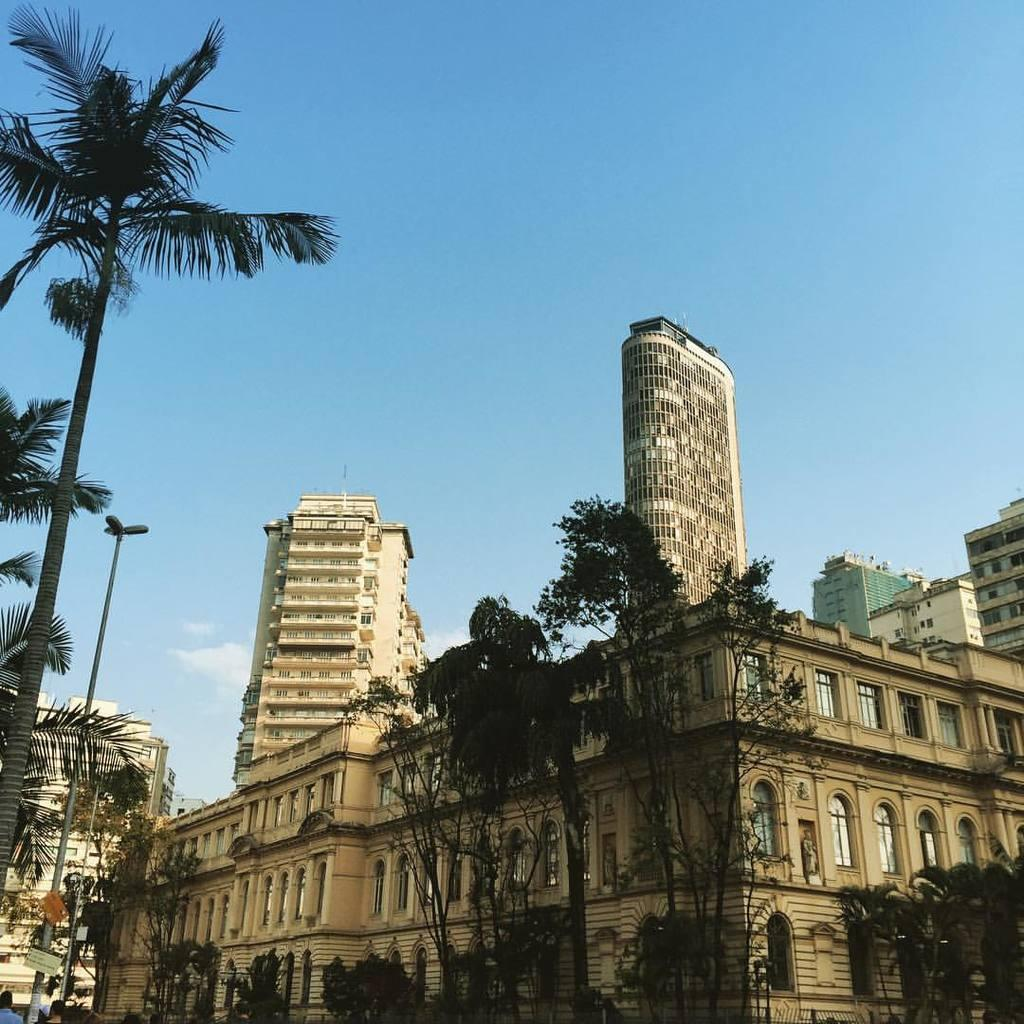What type of structures can be seen in the image? There are buildings in the image. What other natural elements are present in the image? There are trees in the image. What man-made objects can be seen in the image? There are poles and boards in the image. Are there any people in the image? Yes, there are people in the image. What type of illumination is present in the image? There are lights in the image. What is visible at the top of the image? The sky is visible at the top of the image. Can you tell me how many circles are drawn on the pan in the image? There is no pan or circles present in the image. What type of relationship does the person in the image have with their brother? There is no information about a brother or any relationships in the image. 